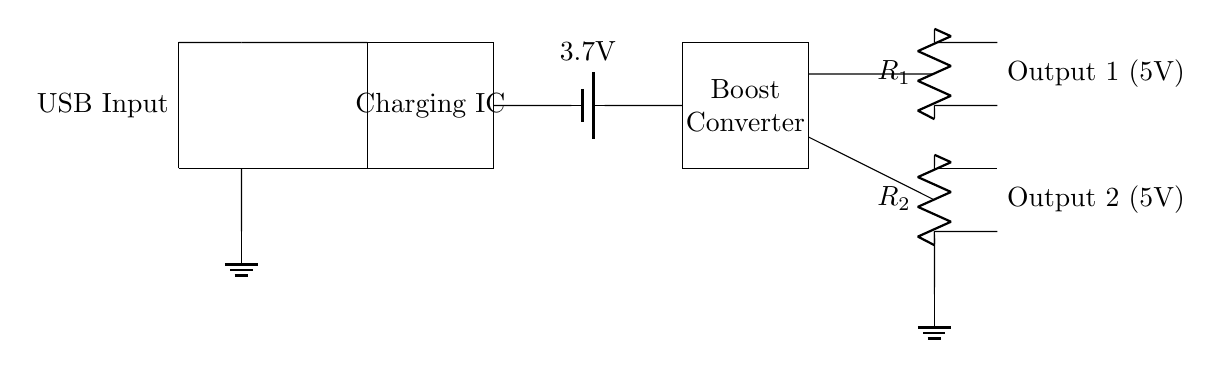What is the input type for this circuit? The circuit diagram indicates a USB Input at the left side, which is a standard connector used for power supply.
Answer: USB Input What is the voltage of the battery in this circuit? The battery in the diagram is labeled as 3.7 volts, which indicates its nominal voltage rating.
Answer: 3.7 volts How many output ports are there in this circuit? The diagram shows two distinct output connections, each identified as Output 1 and Output 2.
Answer: Two What is the role of the boost converter in this circuit? The boost converter is responsible for increasing the voltage from the battery to the required output voltage of 5 volts, which is common for USB devices.
Answer: Voltage increase What resistance values are used for the outputs in this circuit? The diagram shows two resistors labeled R1 and R2 for Output 1 and Output 2, respectively, indicating the circuit includes current limiting resistors for both outputs.
Answer: R1 and R2 What is the expected output voltage for both output ports? The outputs are explicitly labeled as 5 volts, indicating this is the voltage the circuit is designed to provide to connected devices.
Answer: 5 volts What common application can be inferred from this charging circuit? This charging circuit can be used to charge mobile devices like smartphones or tablets via USB, leveraging the dual output design for multiple devices.
Answer: Mobile device charging 